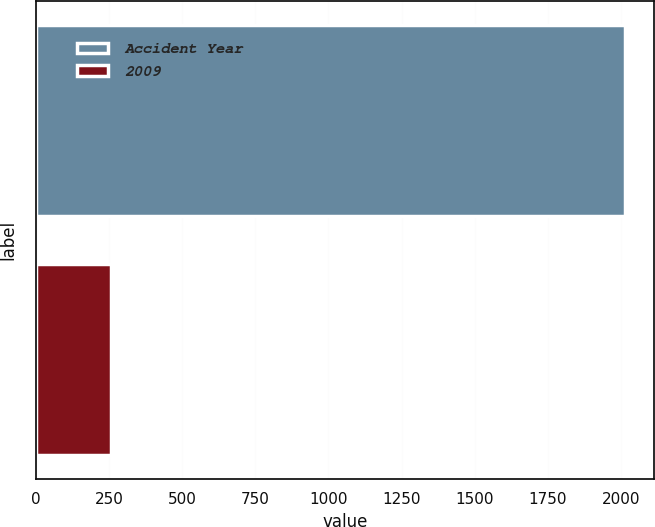Convert chart to OTSL. <chart><loc_0><loc_0><loc_500><loc_500><bar_chart><fcel>Accident Year<fcel>2009<nl><fcel>2014<fcel>257<nl></chart> 